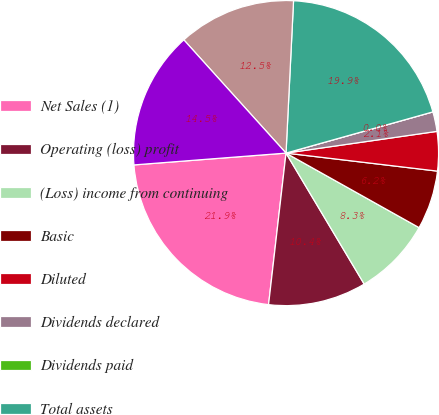Convert chart. <chart><loc_0><loc_0><loc_500><loc_500><pie_chart><fcel>Net Sales (1)<fcel>Operating (loss) profit<fcel>(Loss) income from continuing<fcel>Basic<fcel>Diluted<fcel>Dividends declared<fcel>Dividends paid<fcel>Total assets<fcel>Long-term debt<fcel>Shareholders' equity<nl><fcel>21.94%<fcel>10.39%<fcel>8.31%<fcel>6.24%<fcel>4.16%<fcel>2.08%<fcel>0.0%<fcel>19.86%<fcel>12.47%<fcel>14.55%<nl></chart> 